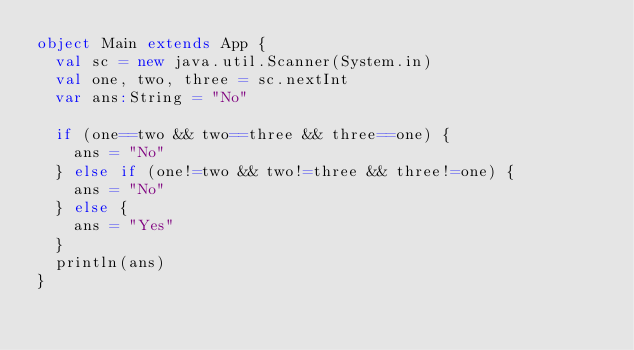Convert code to text. <code><loc_0><loc_0><loc_500><loc_500><_Scala_>object Main extends App {
  val sc = new java.util.Scanner(System.in)
  val one, two, three = sc.nextInt
  var ans:String = "No"
  
  if (one==two && two==three && three==one) {
    ans = "No"
  } else if (one!=two && two!=three && three!=one) {
    ans = "No"
  } else {
    ans = "Yes"
  }
  println(ans)
}
</code> 